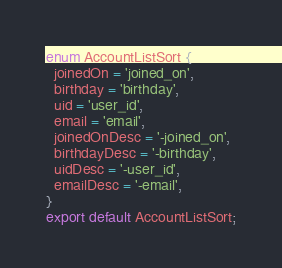<code> <loc_0><loc_0><loc_500><loc_500><_TypeScript_>enum AccountListSort {
  joinedOn = 'joined_on',
  birthday = 'birthday',
  uid = 'user_id',
  email = 'email',
  joinedOnDesc = '-joined_on',
  birthdayDesc = '-birthday',
  uidDesc = '-user_id',
  emailDesc = '-email',
}
export default AccountListSort;
</code> 